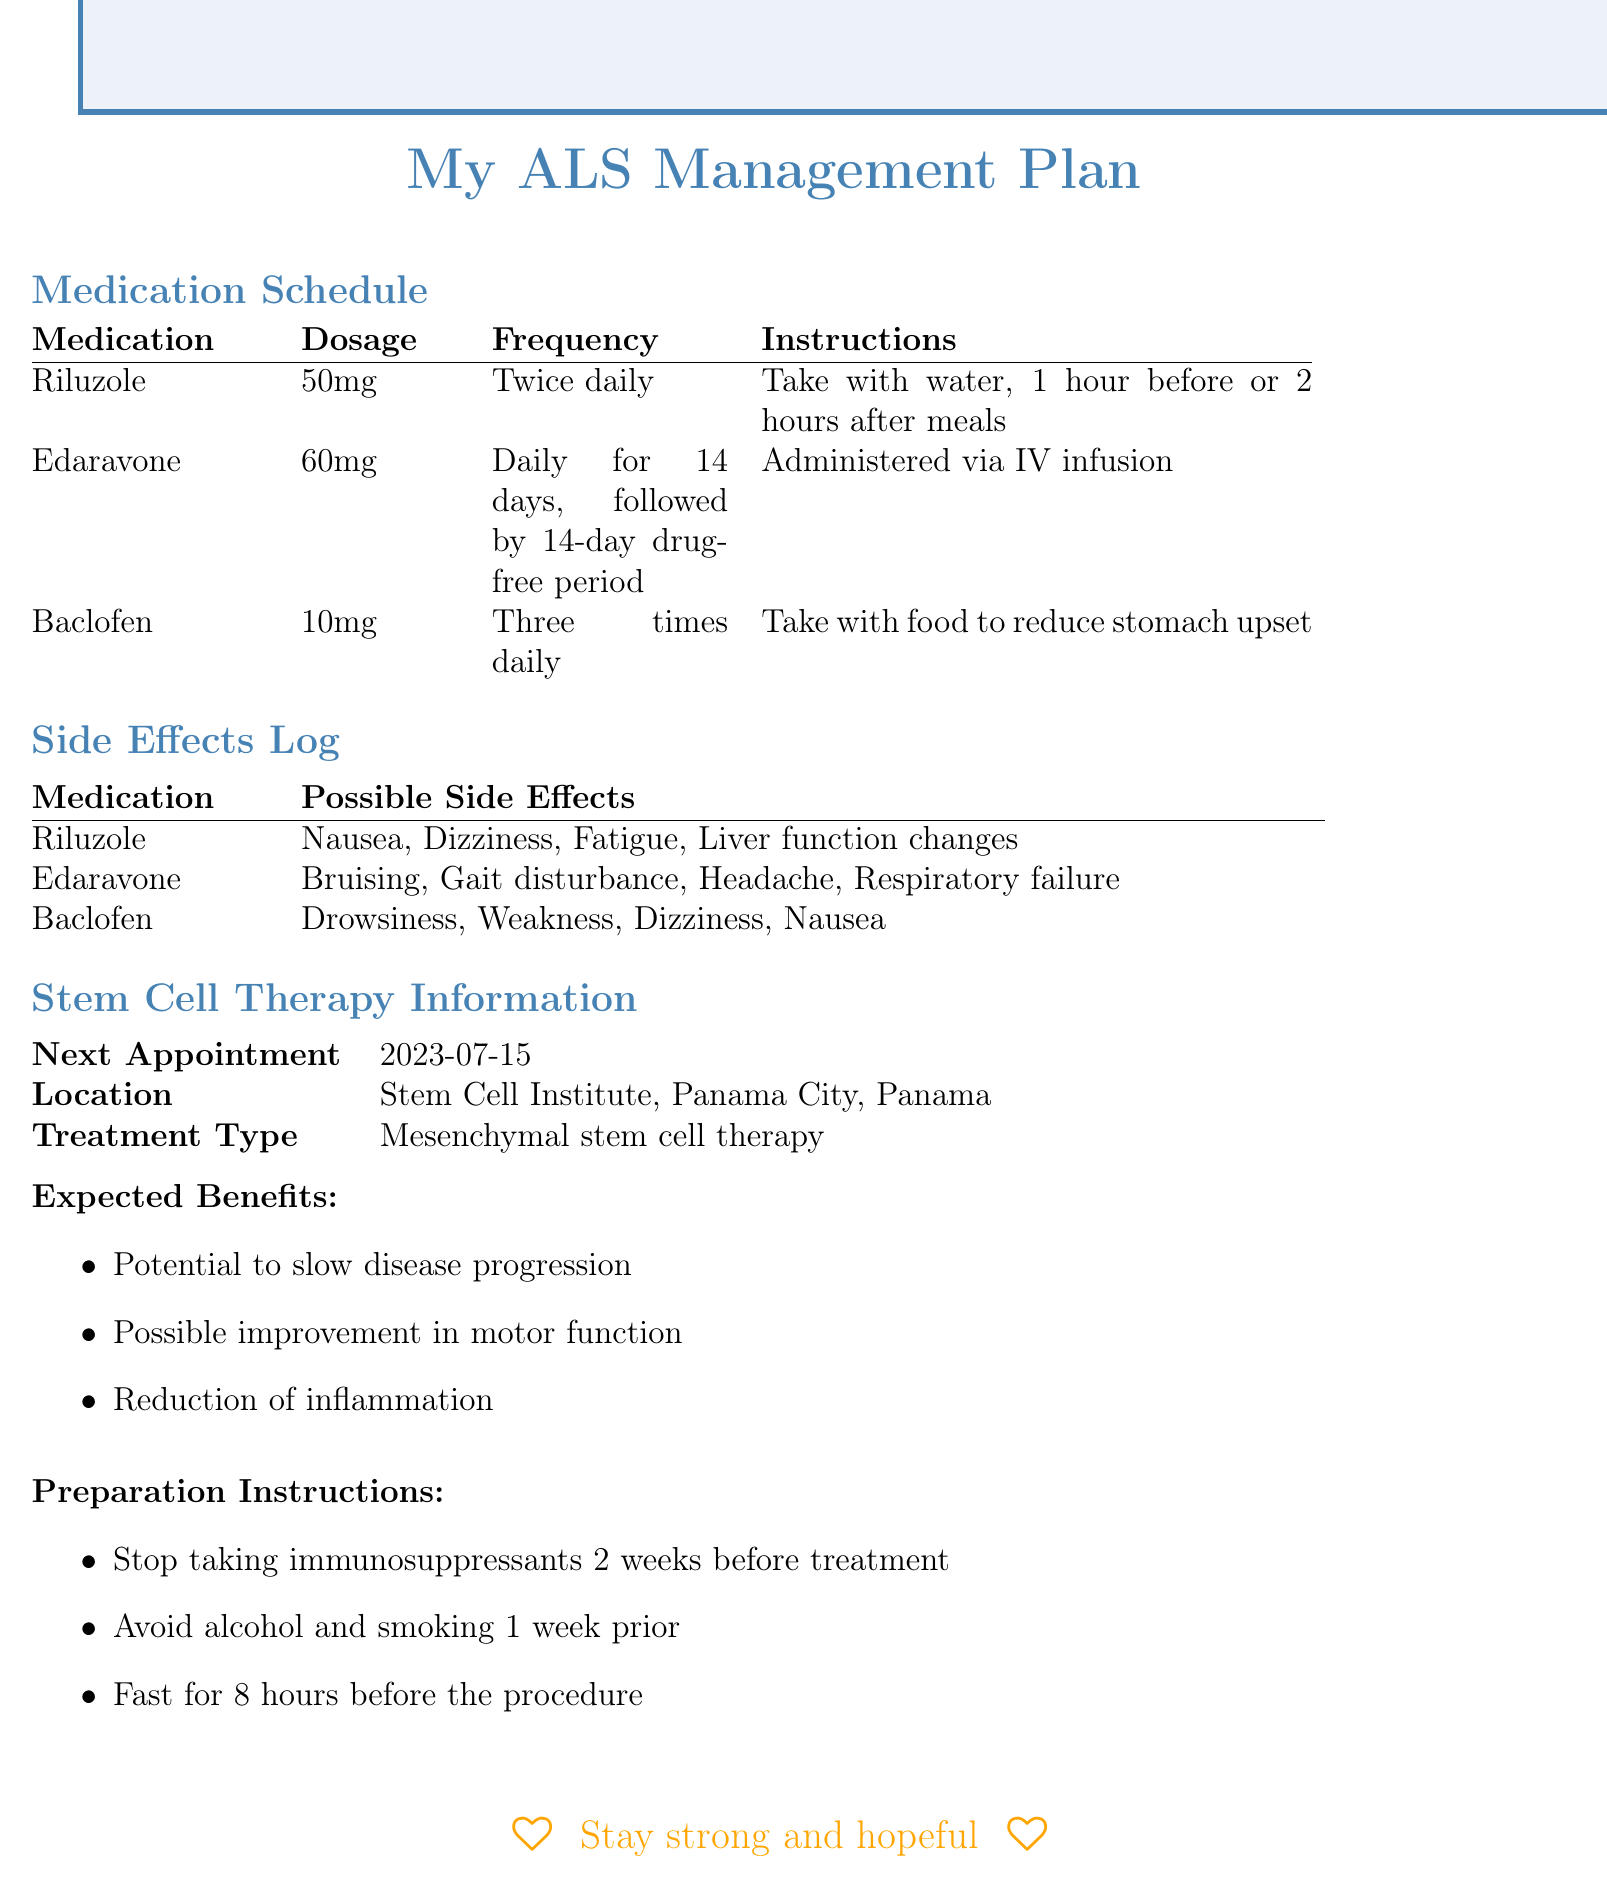What is the medication dosage for Riluzole? The dosage for Riluzole is specified in the medication schedule section of the document.
Answer: 50mg How often should Edaravone be taken? The frequency of Edaravone administration is stated in the medication schedule section.
Answer: Daily for 14 days, followed by 14-day drug-free period What side effect is possible with Baclofen? Possible side effects for Baclofen are listed in the side effects log.
Answer: Drowsiness What are the expected benefits of the stem cell therapy? The expected benefits are enumerated in the stem cell therapy section of the document.
Answer: Potential to slow disease progression What is the location of the next appointment for stem cell therapy? The document specifies the location in the stem cell therapy information section.
Answer: Stem Cell Institute, Panama City, Panama What should be avoided 1 week prior to the stem cell treatment? Preparation instructions mention avoidances related to the treatment.
Answer: Alcohol and smoking How many possible side effects are listed for Edaravone? The document notes possible side effects in the side effects log for Edaravone.
Answer: Four What is the frequency for taking Baclofen? The medication schedule indicates how often Baclofen is to be taken.
Answer: Three times daily What is the treatment type being administered? The type of treatment is described in the stem cell therapy information section.
Answer: Mesenchymal stem cell therapy 